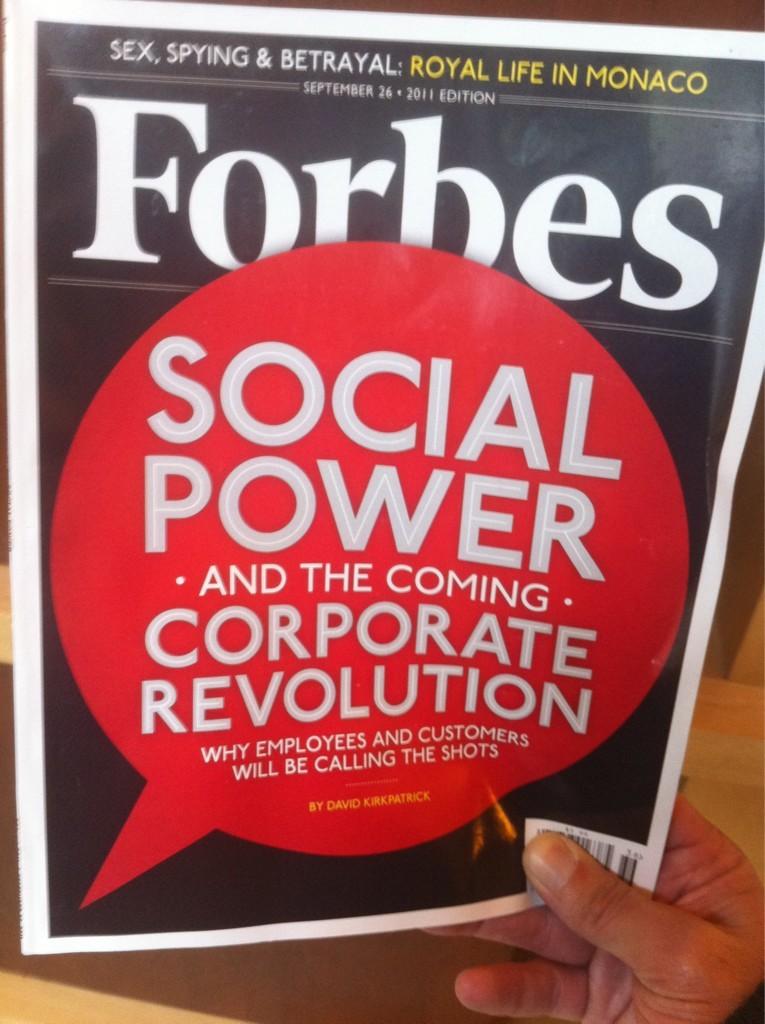What kind of power is wrote on the magazine?
Keep it short and to the point. Social. 